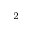<formula> <loc_0><loc_0><loc_500><loc_500>_ { 2 }</formula> 